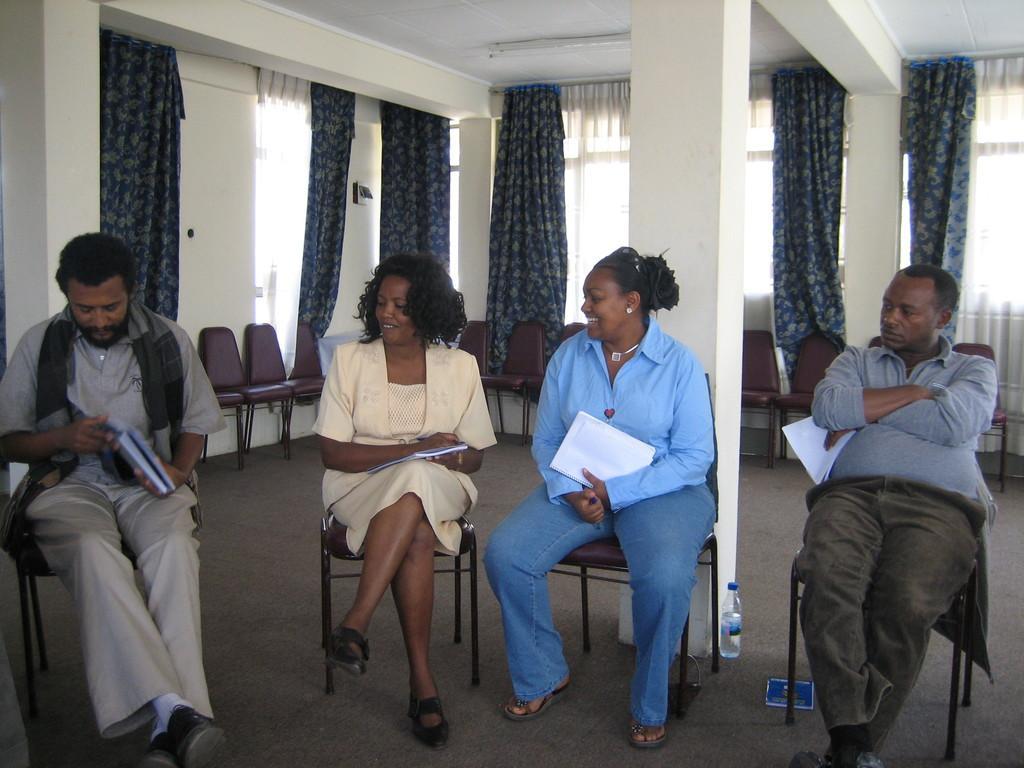Can you describe this image briefly? In this image in front there are four persons sitting on the chairs by holding the book. Behind them there are chairs, curtains. At the bottom of the image there is a mat. 